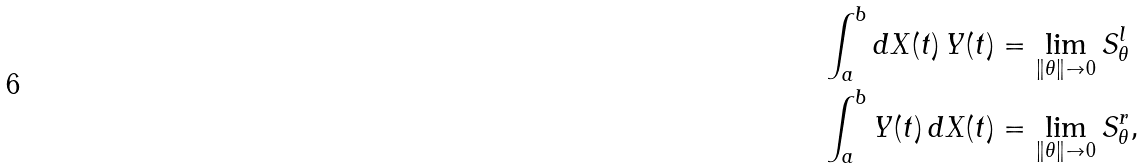Convert formula to latex. <formula><loc_0><loc_0><loc_500><loc_500>& \int _ { a } ^ { b } d X ( t ) \, Y ( t ) = \lim _ { \| \theta \| \to 0 } S _ { \theta } ^ { l } \\ & \int _ { a } ^ { b } Y ( t ) \, d X ( t ) = \lim _ { \| \theta \| \to 0 } S _ { \theta } ^ { r } ,</formula> 